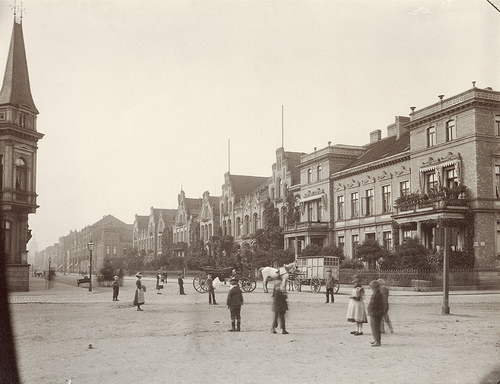<image>What is on top of the steeple? I am not sure. It can be a tower, spire, weathervane, metal, lighting rods, lightening rod, pole or nothing. What type of animals are in the scene? I am not sure what type of animals are in the scene. It could be horses, a dog, or none. What is on top of the steeple? I am not sure what is on top of the steeple. It can be seen 'tower', 'spire', 'weathervane', 'metal', 'lighting rods', 'lightning rod', 'weather vain' or 'pole'. What type of animals are in the scene? I am not sure what type of animals are in the scene. It can be seen horses, dogs, humans or none. 